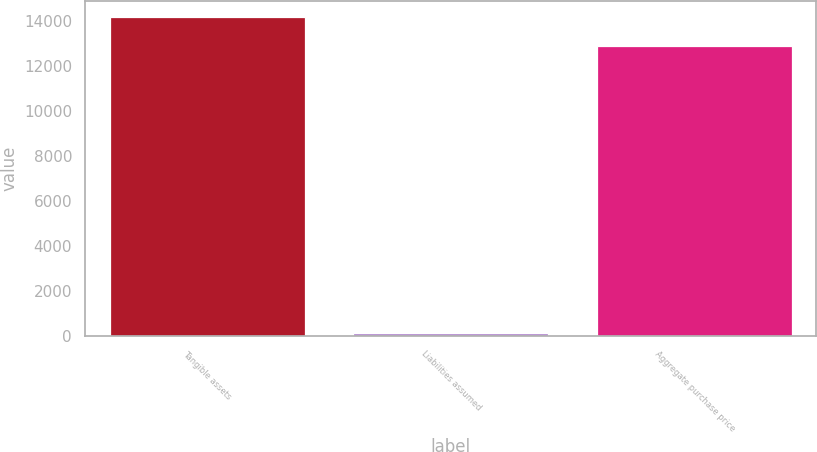Convert chart to OTSL. <chart><loc_0><loc_0><loc_500><loc_500><bar_chart><fcel>Tangible assets<fcel>Liabilities assumed<fcel>Aggregate purchase price<nl><fcel>14184.5<fcel>111<fcel>12895<nl></chart> 